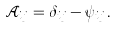<formula> <loc_0><loc_0><loc_500><loc_500>\mathcal { A } _ { i j } = \delta _ { i j } - \psi _ { i j } \, .</formula> 